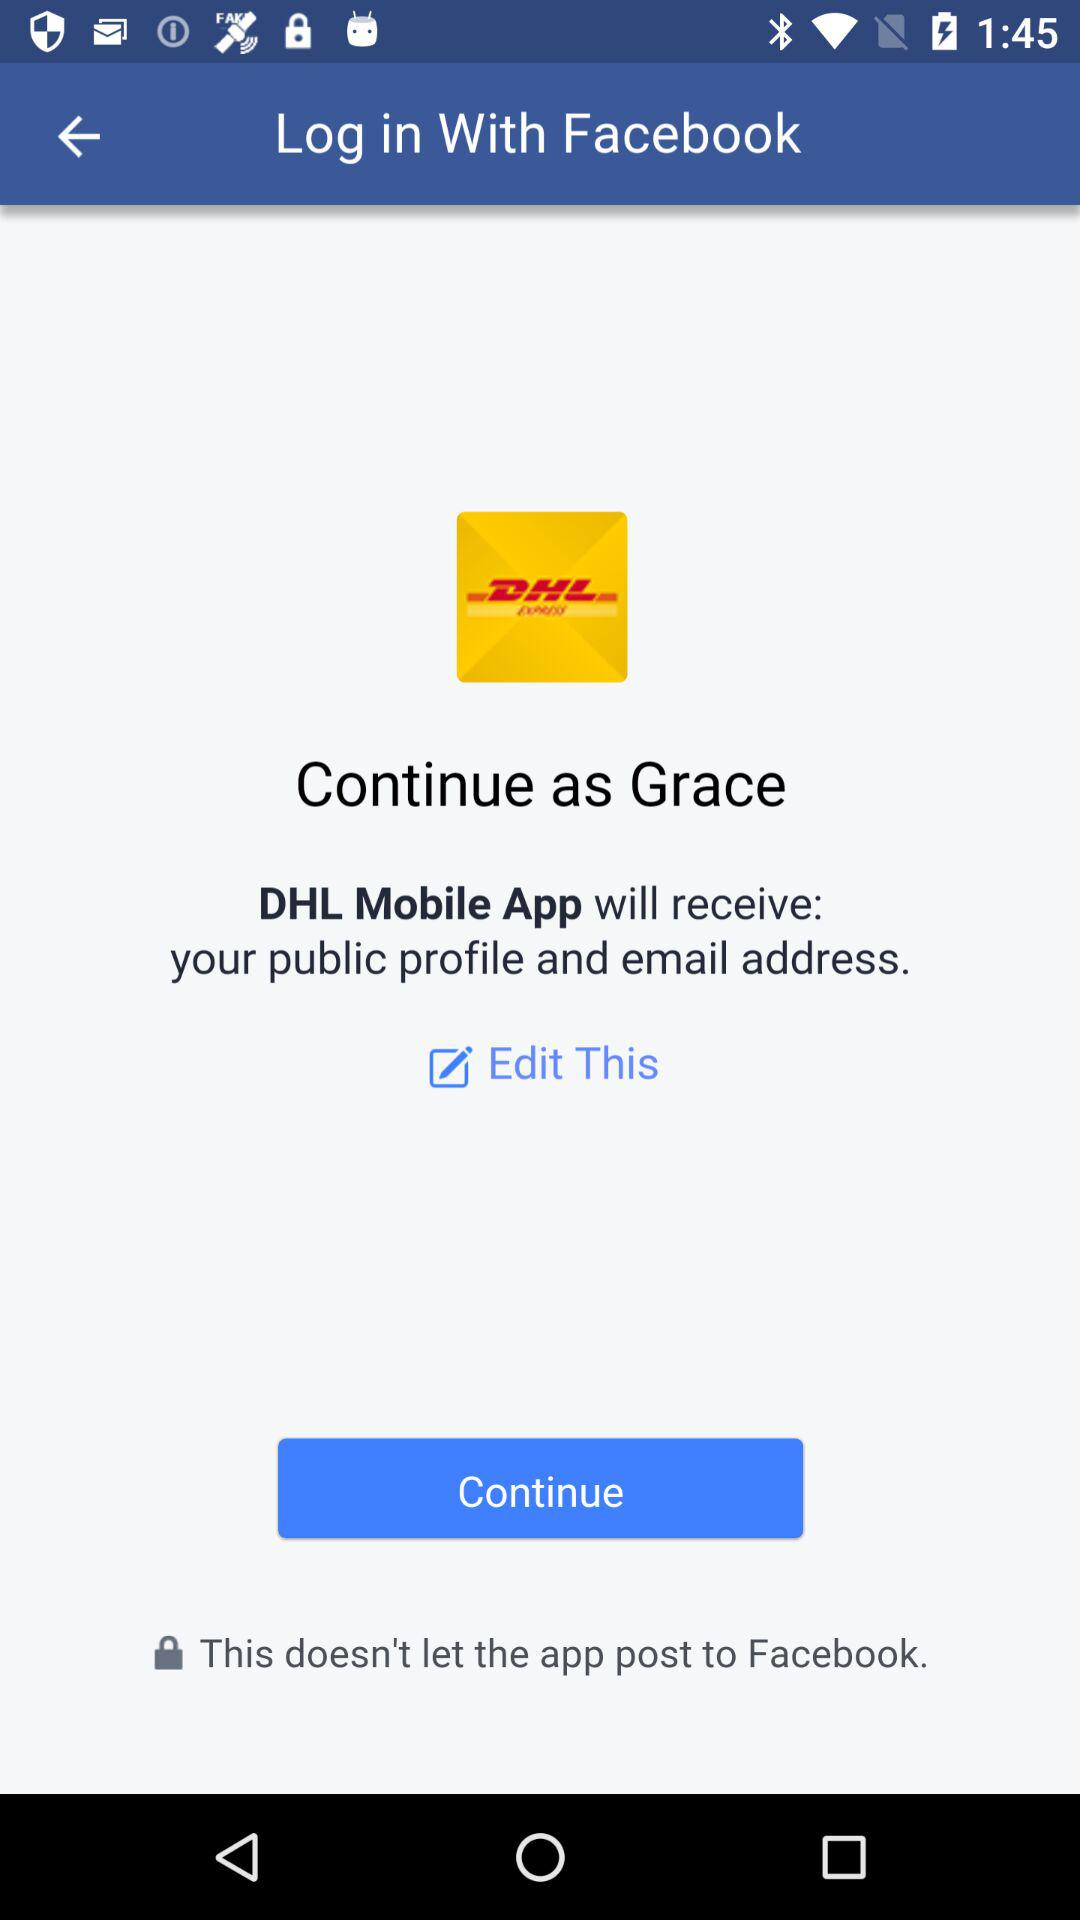What application will receive the public profile and email address? The application "DHL Mobile App" will receive the public profile and email address. 